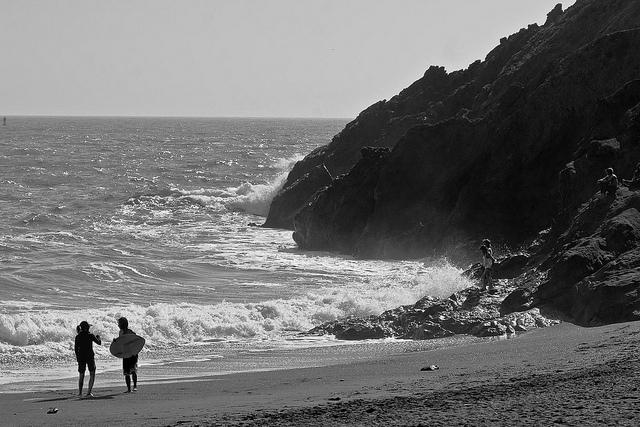What is the man holding?
Keep it brief. Surfboard. Where could there be a ponytail?
Be succinct. On girl. Is the surf rough?
Write a very short answer. Yes. 